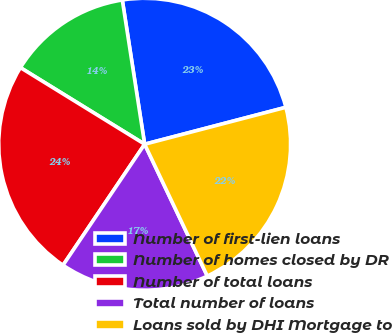Convert chart to OTSL. <chart><loc_0><loc_0><loc_500><loc_500><pie_chart><fcel>Number of first-lien loans<fcel>Number of homes closed by DR<fcel>Number of total loans<fcel>Total number of loans<fcel>Loans sold by DHI Mortgage to<nl><fcel>23.38%<fcel>13.76%<fcel>24.35%<fcel>16.51%<fcel>22.01%<nl></chart> 